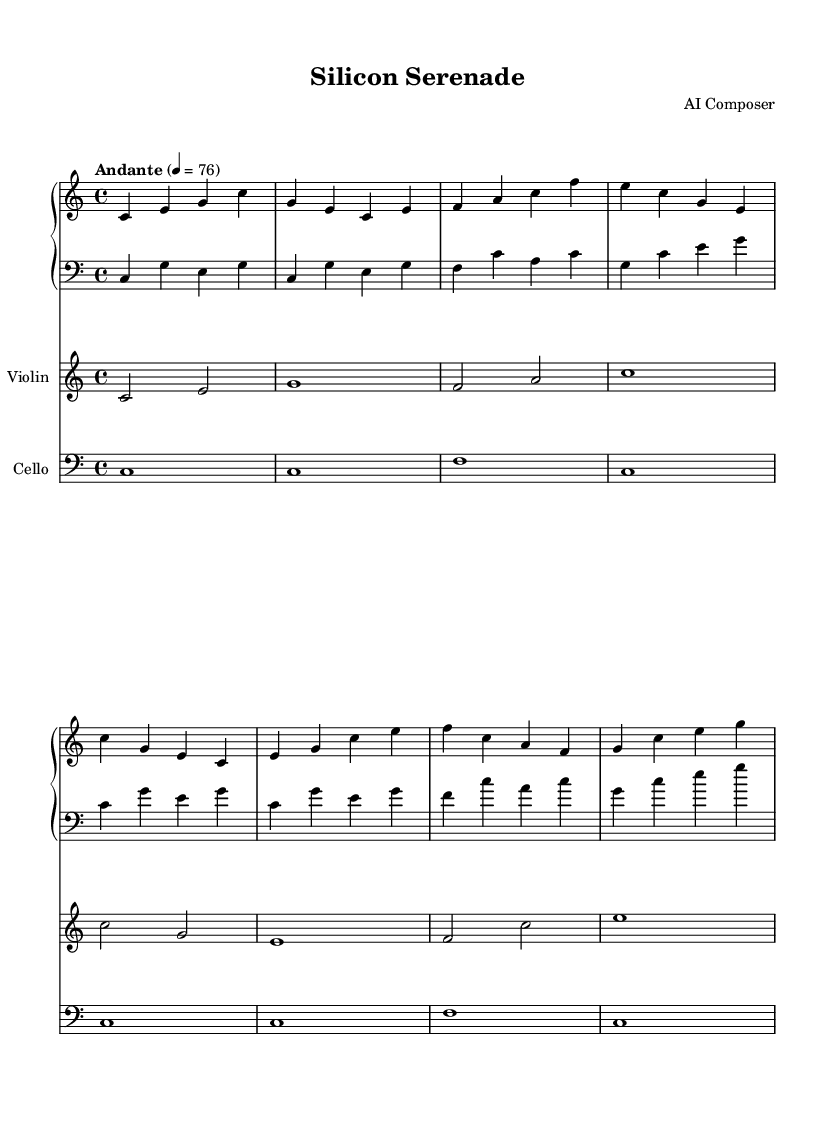What is the key signature of this music? The key signature is indicated at the beginning of the sheet music and shows no sharps or flats, indicating it is in C major.
Answer: C major What is the time signature of this piece? The time signature is represented by two numbers at the beginning of the sheet music, showing 4 beats per measure and a quarter note gets one beat, which is denoted as 4/4.
Answer: 4/4 What is the tempo marking for this composition? The tempo marking is found above the music staff, specifically stating "Andante" with a metronome marking of 76 beats per minute, indicating a moderate pace.
Answer: Andante, 76 How many measures are in the piece? By counting the measures in each staff, we find there are 8 measures total across the score, considering the parts from piano, violin, and cello collectively.
Answer: 8 What is the highest note in the violin part? The highest note is found in the second half of the violin part, specifically noting the C' on the eighth measure, indicating that it is an octave above middle C.
Answer: C' What instruments are featured in this composition? The instruments are listed at the beginning of each staff in the score, showing the presence of piano, violin, and cello, making it a chamber piece for these specific instruments.
Answer: Piano, Violin, Cello What is the rhythmic pattern of the cello part? The cello part consists entirely of whole notes, providing a sustained and consistent rhythmic foundation throughout the piece.
Answer: Whole notes 